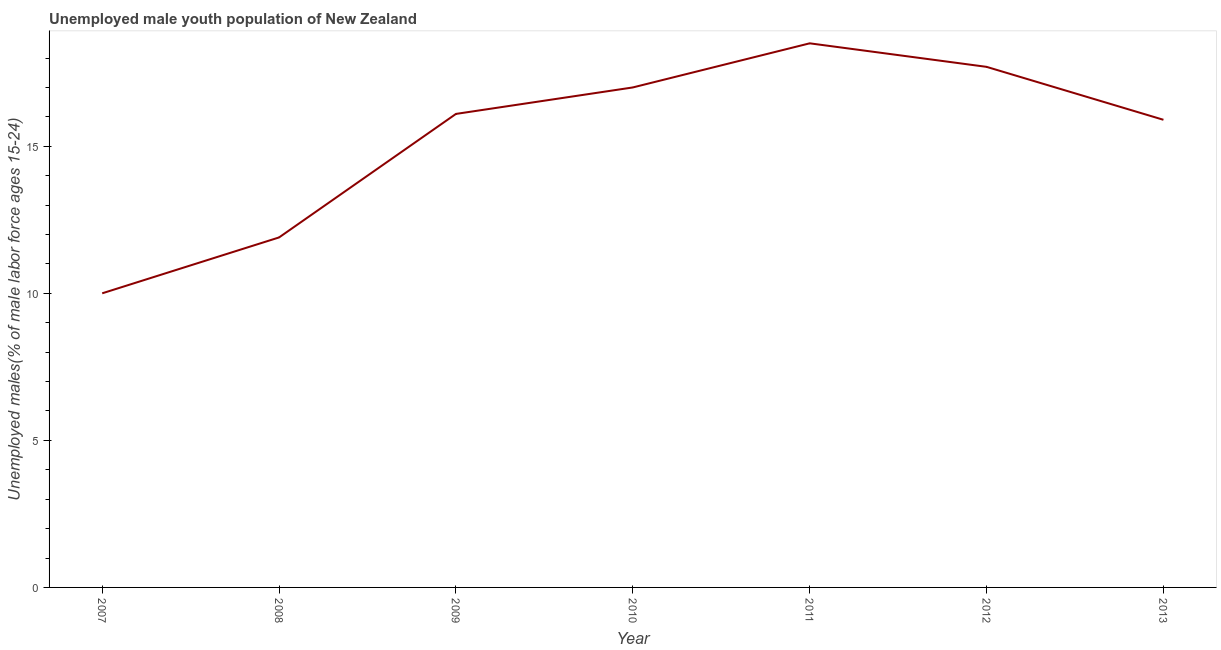What is the unemployed male youth in 2011?
Offer a terse response. 18.5. Across all years, what is the minimum unemployed male youth?
Your answer should be very brief. 10. In which year was the unemployed male youth maximum?
Ensure brevity in your answer.  2011. In which year was the unemployed male youth minimum?
Offer a very short reply. 2007. What is the sum of the unemployed male youth?
Provide a short and direct response. 107.1. What is the difference between the unemployed male youth in 2009 and 2011?
Give a very brief answer. -2.4. What is the average unemployed male youth per year?
Keep it short and to the point. 15.3. What is the median unemployed male youth?
Keep it short and to the point. 16.1. In how many years, is the unemployed male youth greater than 2 %?
Offer a very short reply. 7. Do a majority of the years between 2010 and 2007 (inclusive) have unemployed male youth greater than 6 %?
Your answer should be very brief. Yes. What is the ratio of the unemployed male youth in 2007 to that in 2009?
Your answer should be very brief. 0.62. Is the unemployed male youth in 2007 less than that in 2008?
Keep it short and to the point. Yes. Is the difference between the unemployed male youth in 2009 and 2011 greater than the difference between any two years?
Your answer should be very brief. No. What is the difference between the highest and the second highest unemployed male youth?
Give a very brief answer. 0.8. Is the sum of the unemployed male youth in 2009 and 2013 greater than the maximum unemployed male youth across all years?
Your answer should be very brief. Yes. What is the difference between the highest and the lowest unemployed male youth?
Make the answer very short. 8.5. Does the unemployed male youth monotonically increase over the years?
Your answer should be very brief. No. How many years are there in the graph?
Provide a succinct answer. 7. Are the values on the major ticks of Y-axis written in scientific E-notation?
Your response must be concise. No. What is the title of the graph?
Ensure brevity in your answer.  Unemployed male youth population of New Zealand. What is the label or title of the Y-axis?
Give a very brief answer. Unemployed males(% of male labor force ages 15-24). What is the Unemployed males(% of male labor force ages 15-24) in 2008?
Give a very brief answer. 11.9. What is the Unemployed males(% of male labor force ages 15-24) of 2009?
Ensure brevity in your answer.  16.1. What is the Unemployed males(% of male labor force ages 15-24) in 2010?
Give a very brief answer. 17. What is the Unemployed males(% of male labor force ages 15-24) in 2011?
Ensure brevity in your answer.  18.5. What is the Unemployed males(% of male labor force ages 15-24) in 2012?
Give a very brief answer. 17.7. What is the Unemployed males(% of male labor force ages 15-24) of 2013?
Offer a terse response. 15.9. What is the difference between the Unemployed males(% of male labor force ages 15-24) in 2007 and 2008?
Your answer should be compact. -1.9. What is the difference between the Unemployed males(% of male labor force ages 15-24) in 2007 and 2009?
Provide a short and direct response. -6.1. What is the difference between the Unemployed males(% of male labor force ages 15-24) in 2007 and 2010?
Offer a very short reply. -7. What is the difference between the Unemployed males(% of male labor force ages 15-24) in 2007 and 2013?
Give a very brief answer. -5.9. What is the difference between the Unemployed males(% of male labor force ages 15-24) in 2008 and 2010?
Ensure brevity in your answer.  -5.1. What is the difference between the Unemployed males(% of male labor force ages 15-24) in 2008 and 2011?
Give a very brief answer. -6.6. What is the difference between the Unemployed males(% of male labor force ages 15-24) in 2009 and 2011?
Offer a very short reply. -2.4. What is the difference between the Unemployed males(% of male labor force ages 15-24) in 2009 and 2012?
Make the answer very short. -1.6. What is the difference between the Unemployed males(% of male labor force ages 15-24) in 2010 and 2011?
Provide a succinct answer. -1.5. What is the difference between the Unemployed males(% of male labor force ages 15-24) in 2010 and 2013?
Your answer should be very brief. 1.1. What is the ratio of the Unemployed males(% of male labor force ages 15-24) in 2007 to that in 2008?
Your response must be concise. 0.84. What is the ratio of the Unemployed males(% of male labor force ages 15-24) in 2007 to that in 2009?
Offer a terse response. 0.62. What is the ratio of the Unemployed males(% of male labor force ages 15-24) in 2007 to that in 2010?
Keep it short and to the point. 0.59. What is the ratio of the Unemployed males(% of male labor force ages 15-24) in 2007 to that in 2011?
Offer a very short reply. 0.54. What is the ratio of the Unemployed males(% of male labor force ages 15-24) in 2007 to that in 2012?
Give a very brief answer. 0.56. What is the ratio of the Unemployed males(% of male labor force ages 15-24) in 2007 to that in 2013?
Keep it short and to the point. 0.63. What is the ratio of the Unemployed males(% of male labor force ages 15-24) in 2008 to that in 2009?
Ensure brevity in your answer.  0.74. What is the ratio of the Unemployed males(% of male labor force ages 15-24) in 2008 to that in 2010?
Offer a terse response. 0.7. What is the ratio of the Unemployed males(% of male labor force ages 15-24) in 2008 to that in 2011?
Keep it short and to the point. 0.64. What is the ratio of the Unemployed males(% of male labor force ages 15-24) in 2008 to that in 2012?
Provide a succinct answer. 0.67. What is the ratio of the Unemployed males(% of male labor force ages 15-24) in 2008 to that in 2013?
Provide a short and direct response. 0.75. What is the ratio of the Unemployed males(% of male labor force ages 15-24) in 2009 to that in 2010?
Your answer should be very brief. 0.95. What is the ratio of the Unemployed males(% of male labor force ages 15-24) in 2009 to that in 2011?
Offer a terse response. 0.87. What is the ratio of the Unemployed males(% of male labor force ages 15-24) in 2009 to that in 2012?
Your response must be concise. 0.91. What is the ratio of the Unemployed males(% of male labor force ages 15-24) in 2009 to that in 2013?
Keep it short and to the point. 1.01. What is the ratio of the Unemployed males(% of male labor force ages 15-24) in 2010 to that in 2011?
Your answer should be very brief. 0.92. What is the ratio of the Unemployed males(% of male labor force ages 15-24) in 2010 to that in 2013?
Provide a succinct answer. 1.07. What is the ratio of the Unemployed males(% of male labor force ages 15-24) in 2011 to that in 2012?
Keep it short and to the point. 1.04. What is the ratio of the Unemployed males(% of male labor force ages 15-24) in 2011 to that in 2013?
Your answer should be very brief. 1.16. What is the ratio of the Unemployed males(% of male labor force ages 15-24) in 2012 to that in 2013?
Provide a short and direct response. 1.11. 